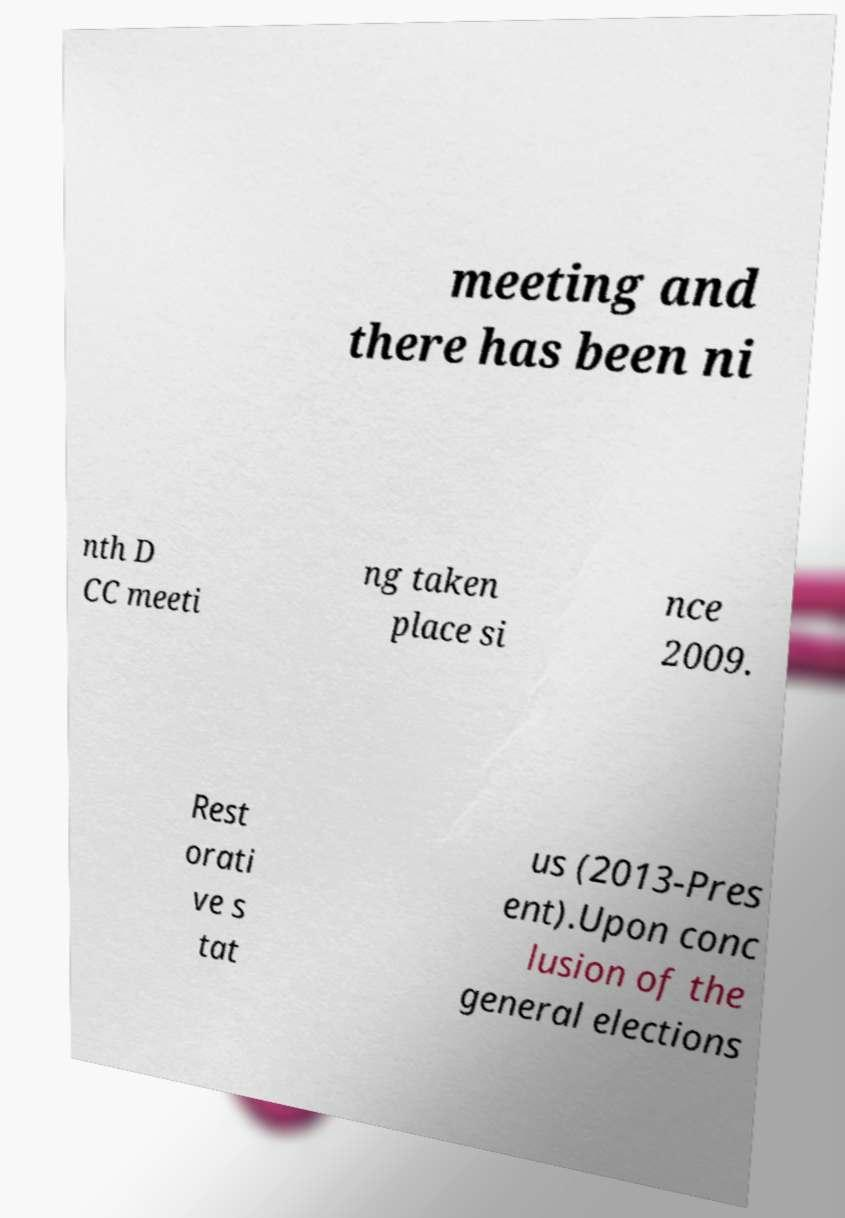For documentation purposes, I need the text within this image transcribed. Could you provide that? meeting and there has been ni nth D CC meeti ng taken place si nce 2009. Rest orati ve s tat us (2013-Pres ent).Upon conc lusion of the general elections 